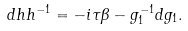<formula> <loc_0><loc_0><loc_500><loc_500>d h h ^ { - 1 } = - i \tau \beta - g ^ { - 1 } _ { 1 } d g _ { 1 } .</formula> 